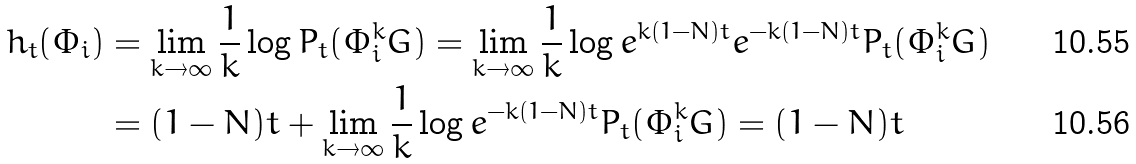<formula> <loc_0><loc_0><loc_500><loc_500>h _ { t } ( \Phi _ { i } ) & = \lim _ { k \to \infty } \frac { 1 } { k } \log P _ { t } ( \Phi _ { i } ^ { k } G ) = \lim _ { k \to \infty } \frac { 1 } { k } \log e ^ { k ( 1 - N ) t } e ^ { - k ( 1 - N ) t } P _ { t } ( \Phi _ { i } ^ { k } G ) \\ & = ( 1 - N ) t + \lim _ { k \to \infty } \frac { 1 } { k } \log e ^ { - k ( 1 - N ) t } P _ { t } ( \Phi _ { i } ^ { k } G ) = ( 1 - N ) t</formula> 